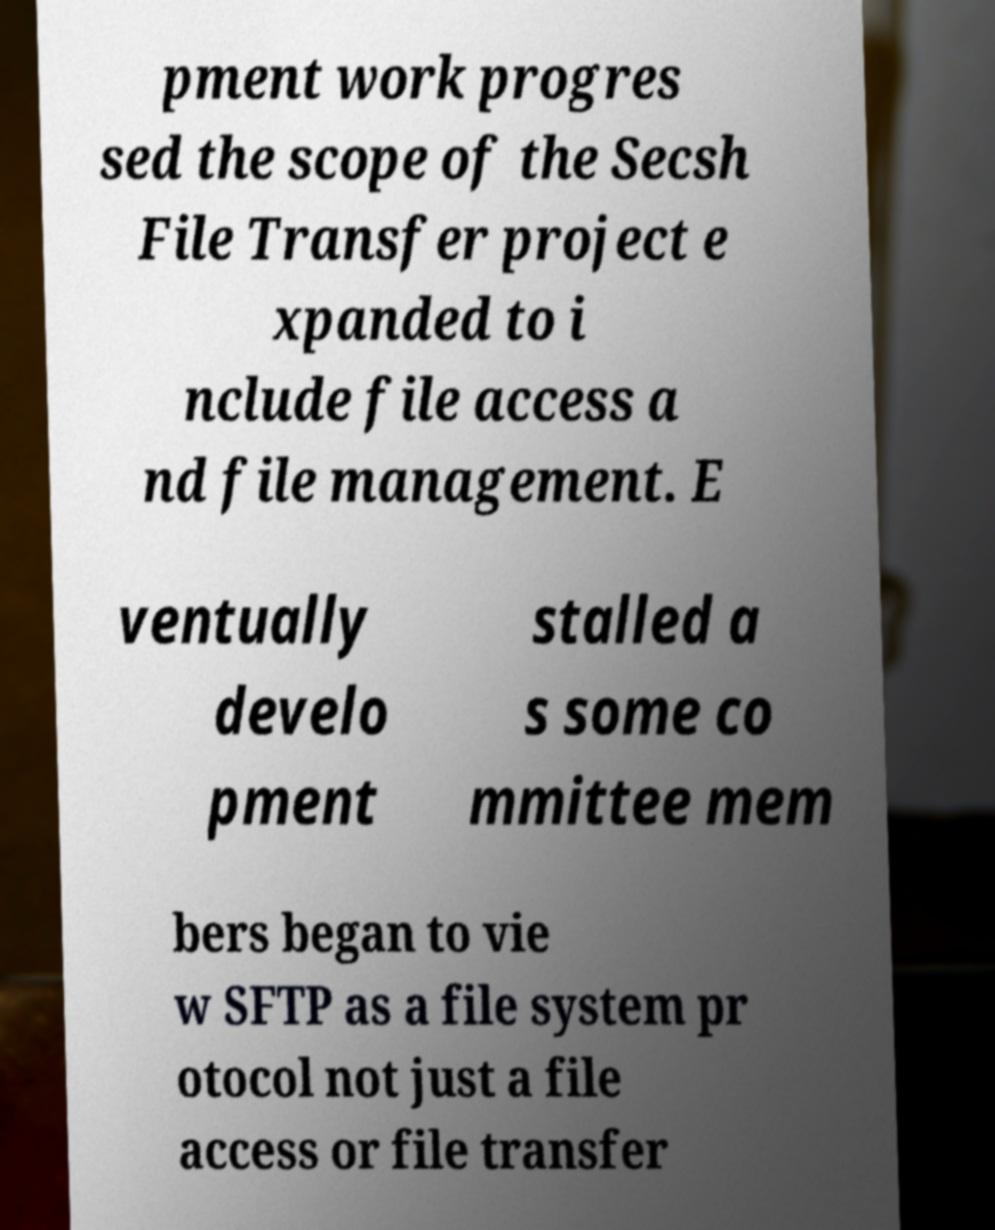Can you read and provide the text displayed in the image?This photo seems to have some interesting text. Can you extract and type it out for me? pment work progres sed the scope of the Secsh File Transfer project e xpanded to i nclude file access a nd file management. E ventually develo pment stalled a s some co mmittee mem bers began to vie w SFTP as a file system pr otocol not just a file access or file transfer 